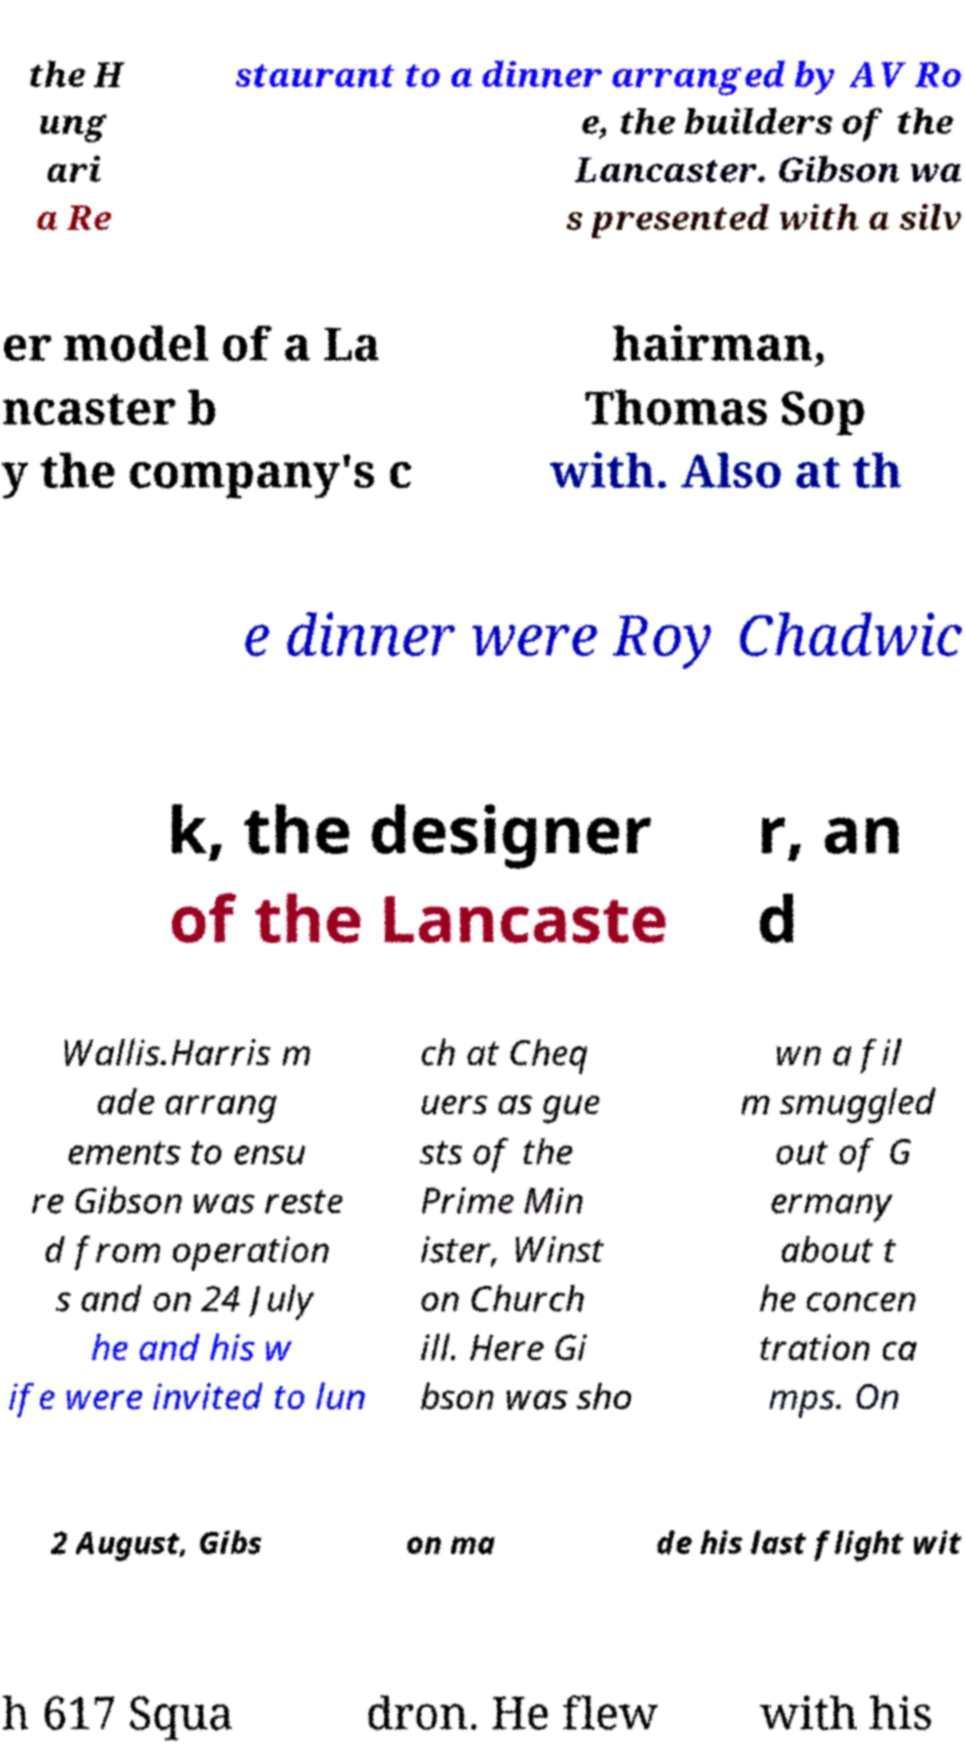Could you extract and type out the text from this image? the H ung ari a Re staurant to a dinner arranged by AV Ro e, the builders of the Lancaster. Gibson wa s presented with a silv er model of a La ncaster b y the company's c hairman, Thomas Sop with. Also at th e dinner were Roy Chadwic k, the designer of the Lancaste r, an d Wallis.Harris m ade arrang ements to ensu re Gibson was reste d from operation s and on 24 July he and his w ife were invited to lun ch at Cheq uers as gue sts of the Prime Min ister, Winst on Church ill. Here Gi bson was sho wn a fil m smuggled out of G ermany about t he concen tration ca mps. On 2 August, Gibs on ma de his last flight wit h 617 Squa dron. He flew with his 